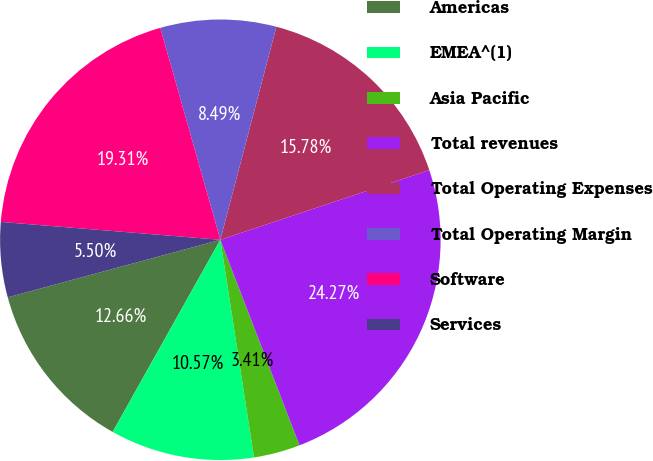Convert chart. <chart><loc_0><loc_0><loc_500><loc_500><pie_chart><fcel>Americas<fcel>EMEA^(1)<fcel>Asia Pacific<fcel>Total revenues<fcel>Total Operating Expenses<fcel>Total Operating Margin<fcel>Software<fcel>Services<nl><fcel>12.66%<fcel>10.57%<fcel>3.41%<fcel>24.27%<fcel>15.78%<fcel>8.49%<fcel>19.31%<fcel>5.5%<nl></chart> 